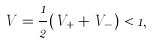<formula> <loc_0><loc_0><loc_500><loc_500>V = \frac { 1 } { 2 } ( V _ { + } + V _ { - } ) < 1 ,</formula> 